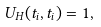<formula> <loc_0><loc_0><loc_500><loc_500>U _ { H } ( t _ { i } , t _ { i } ) = { 1 } ,</formula> 